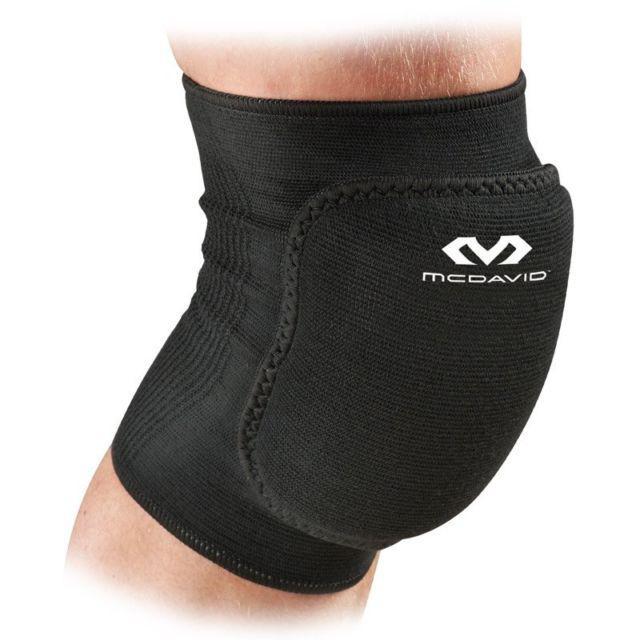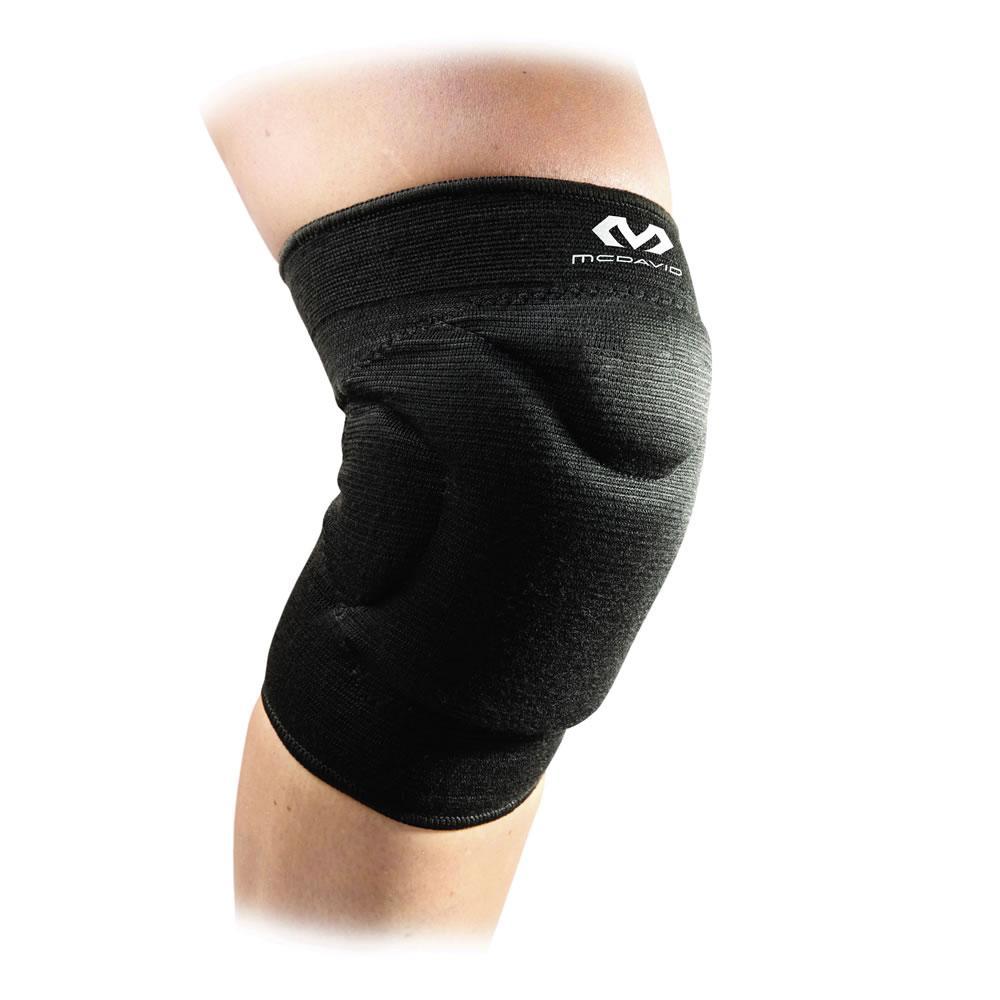The first image is the image on the left, the second image is the image on the right. For the images shown, is this caption "The left and right image contains the same number of medium size knee braces." true? Answer yes or no. Yes. The first image is the image on the left, the second image is the image on the right. Evaluate the accuracy of this statement regarding the images: "Each image shows at least one human leg, and at least one image features a long black compression wrap with a knee pad on its front worn on a leg.". Is it true? Answer yes or no. No. 